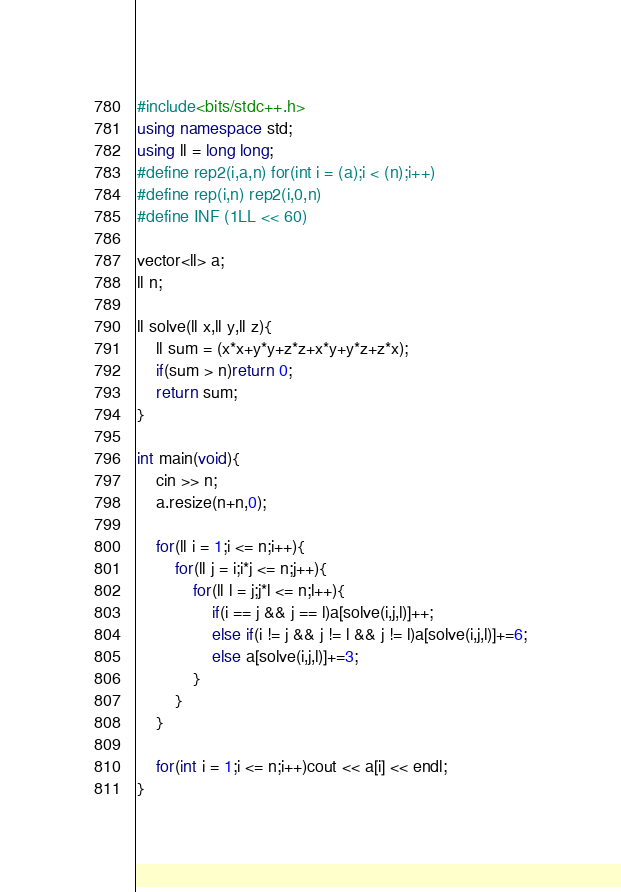<code> <loc_0><loc_0><loc_500><loc_500><_C++_>#include<bits/stdc++.h>
using namespace std;
using ll = long long;
#define rep2(i,a,n) for(int i = (a);i < (n);i++)
#define rep(i,n) rep2(i,0,n)
#define INF (1LL << 60)

vector<ll> a;
ll n;

ll solve(ll x,ll y,ll z){
    ll sum = (x*x+y*y+z*z+x*y+y*z+z*x);
    if(sum > n)return 0;
    return sum;
}

int main(void){
    cin >> n;
    a.resize(n+n,0);
    
    for(ll i = 1;i <= n;i++){
        for(ll j = i;i*j <= n;j++){
            for(ll l = j;j*l <= n;l++){
                if(i == j && j == l)a[solve(i,j,l)]++;
                else if(i != j && j != l && j != l)a[solve(i,j,l)]+=6;
                else a[solve(i,j,l)]+=3;
            }
        }
    }
    
    for(int i = 1;i <= n;i++)cout << a[i] << endl;
}
</code> 